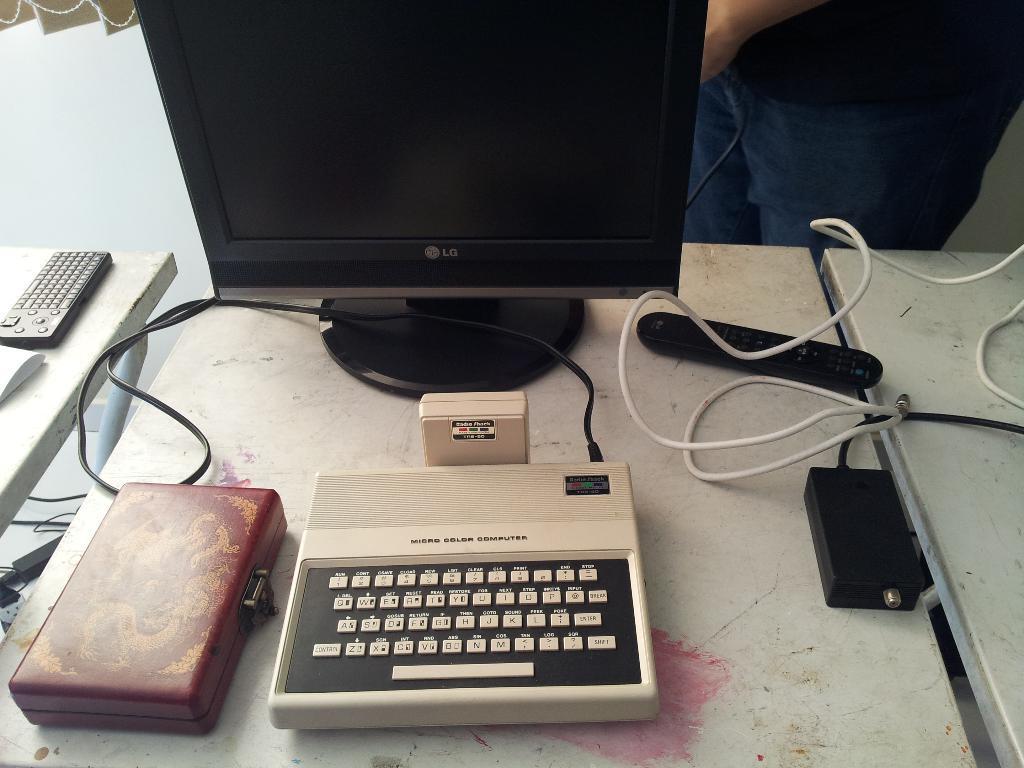Describe this image in one or two sentences. In front of the image there are tables. On top of it there is a computer and there are a few other objects. Behind the tables there is a person. In the background of the image there is a wall and there is a curtain. 